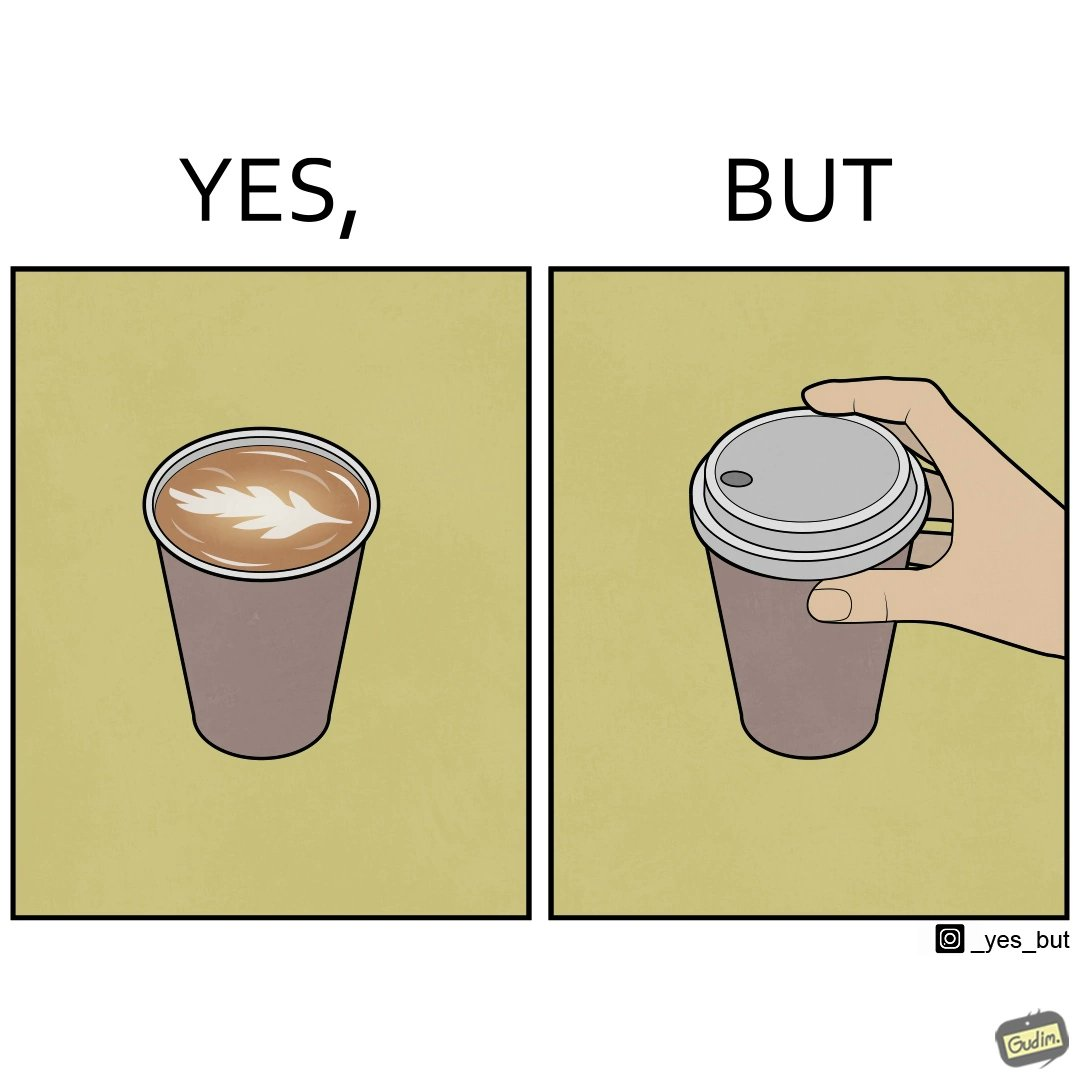Explain why this image is satirical. The images are funny since it shows how someone has put effort into a cup of coffee to do latte art on it only for it to be invisible after a lid is put on the coffee cup before serving to a customer 